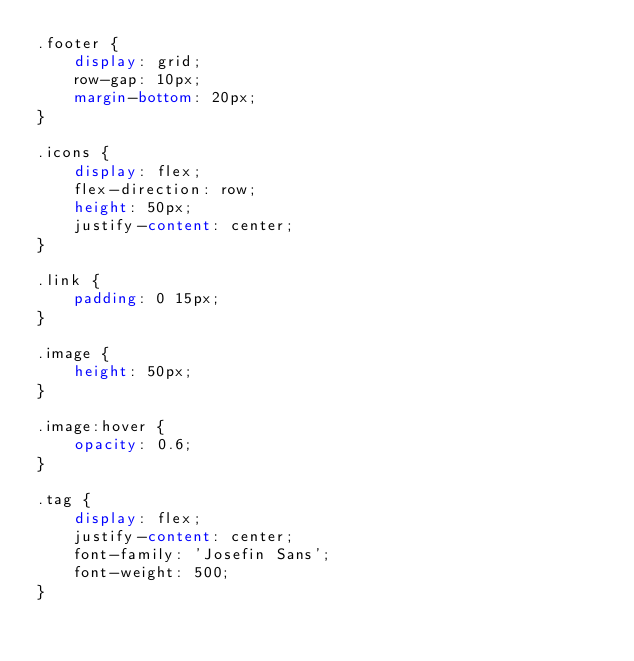Convert code to text. <code><loc_0><loc_0><loc_500><loc_500><_CSS_>.footer {
	display: grid;
	row-gap: 10px;
	margin-bottom: 20px;
}

.icons {
	display: flex;
	flex-direction: row;
	height: 50px;
	justify-content: center;
}

.link {
	padding: 0 15px;
}

.image {
	height: 50px;
}

.image:hover {
	opacity: 0.6;
}

.tag {
	display: flex;
	justify-content: center;
	font-family: 'Josefin Sans';
	font-weight: 500;
}</code> 